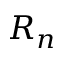Convert formula to latex. <formula><loc_0><loc_0><loc_500><loc_500>R _ { n }</formula> 